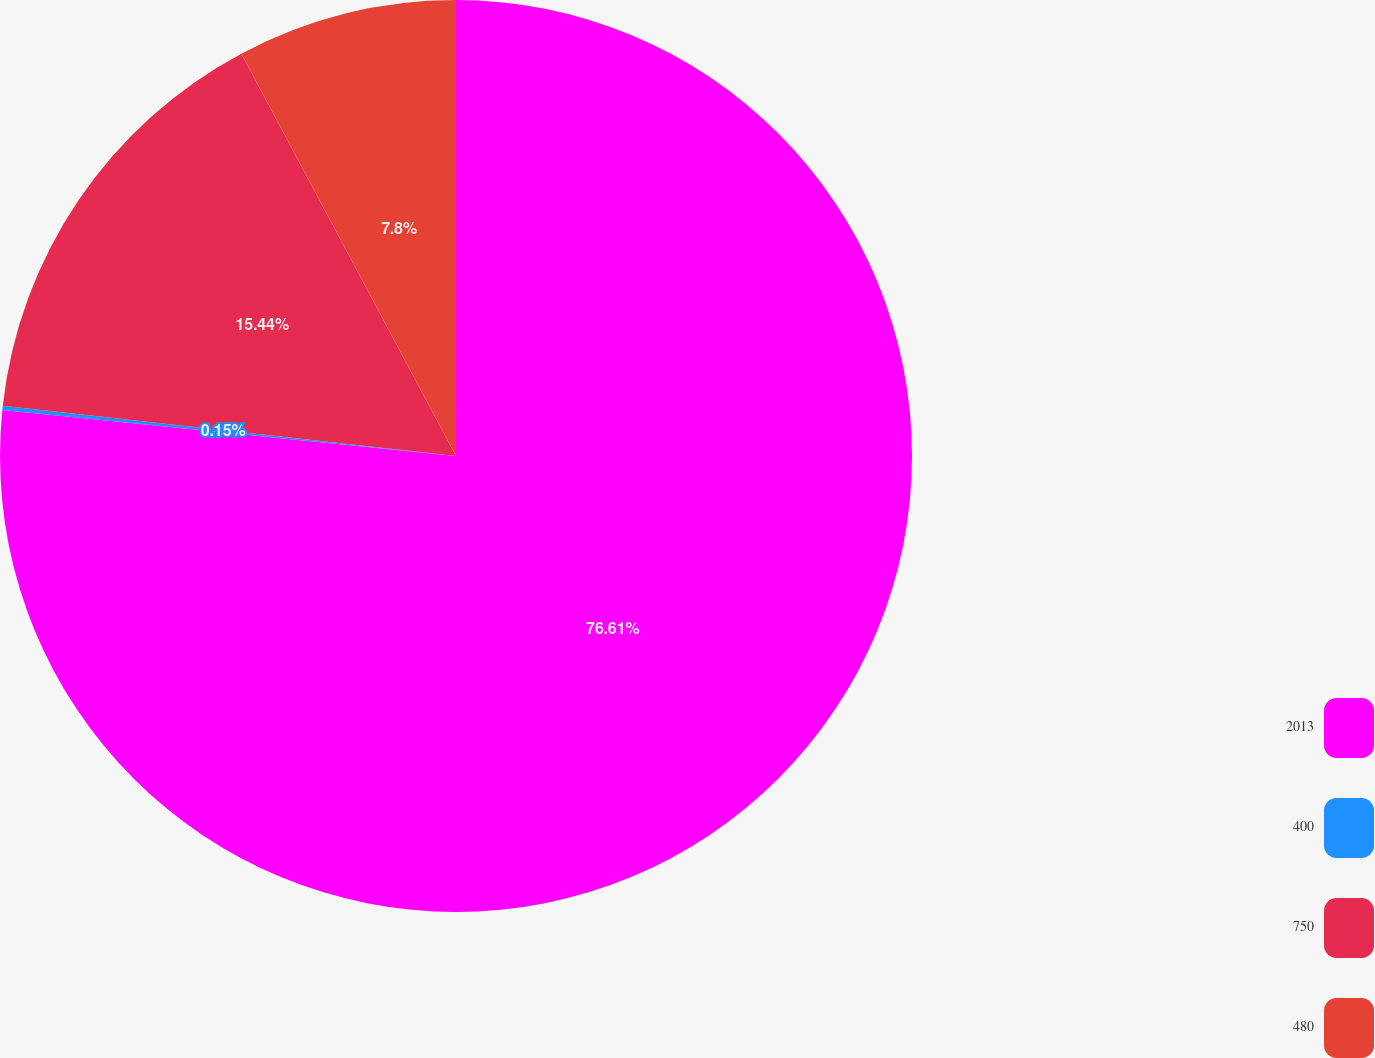Convert chart to OTSL. <chart><loc_0><loc_0><loc_500><loc_500><pie_chart><fcel>2013<fcel>400<fcel>750<fcel>480<nl><fcel>76.61%<fcel>0.15%<fcel>15.44%<fcel>7.8%<nl></chart> 